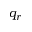Convert formula to latex. <formula><loc_0><loc_0><loc_500><loc_500>q _ { r }</formula> 